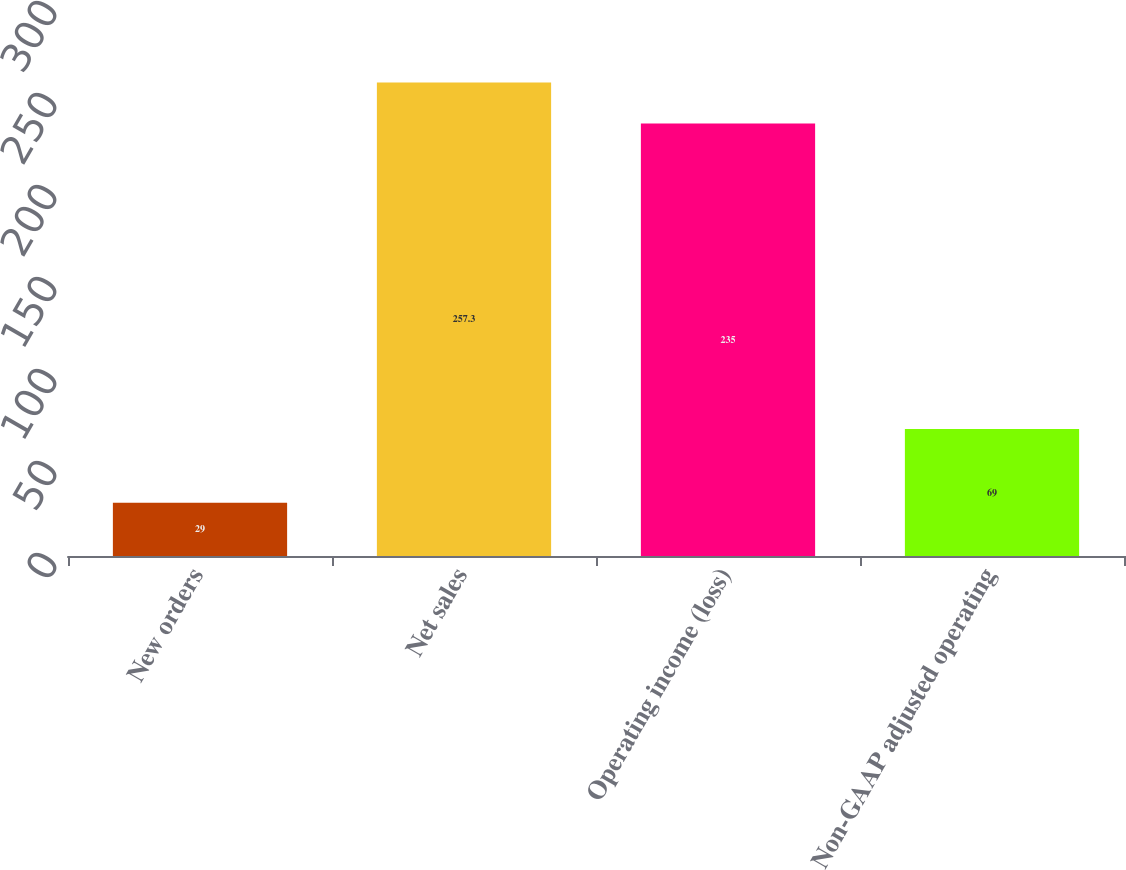<chart> <loc_0><loc_0><loc_500><loc_500><bar_chart><fcel>New orders<fcel>Net sales<fcel>Operating income (loss)<fcel>Non-GAAP adjusted operating<nl><fcel>29<fcel>257.3<fcel>235<fcel>69<nl></chart> 